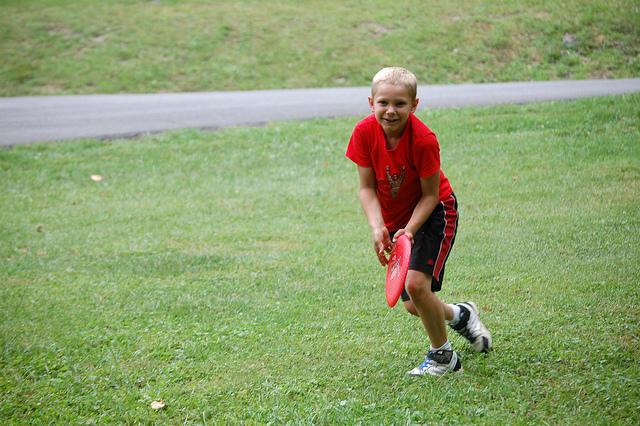Is this boy blond??
Give a very brief answer. Yes. How old is this kid?
Answer briefly. 10. Is he a jockey?
Short answer required. No. What color is the boys shirt?
Give a very brief answer. Red. How many people are there?
Keep it brief. 1. Is he wearing shoes?
Be succinct. Yes. Is that a handrail in the background?
Short answer required. No. Which foot is behind the other?
Keep it brief. Right. 